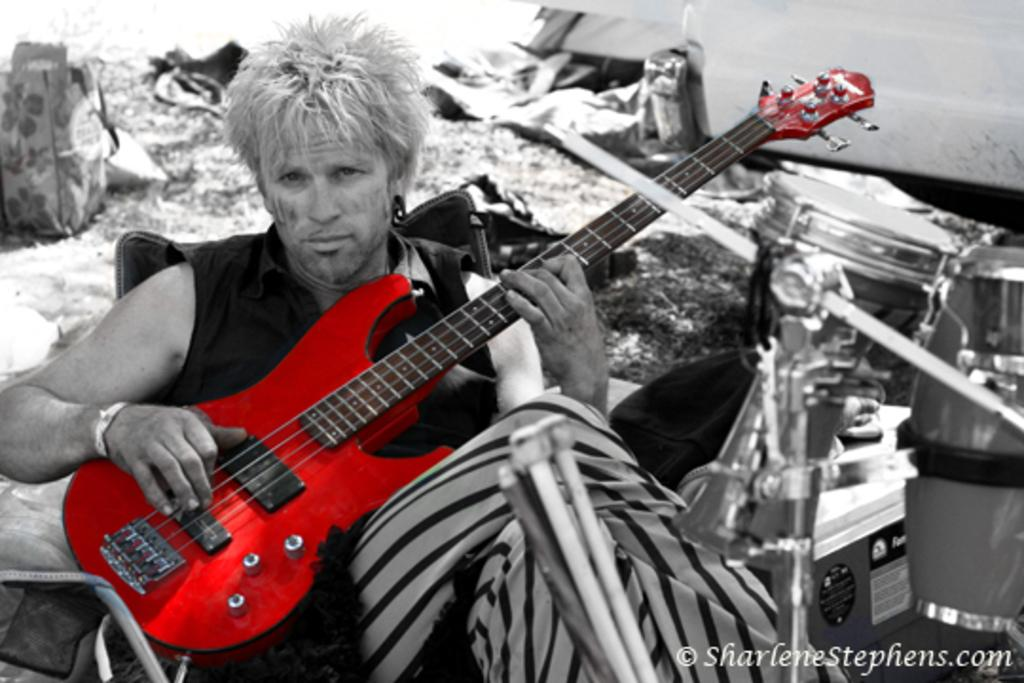What is the man in the image doing? The man is playing the guitar. What is the man wearing in the image? The man is wearing a jacket. Where is the sink located in the image? There is no sink present in the image. What type of trousers is the man wearing in the image? The provided facts do not mention the type of trousers the man is wearing, only that he is wearing a jacket. 